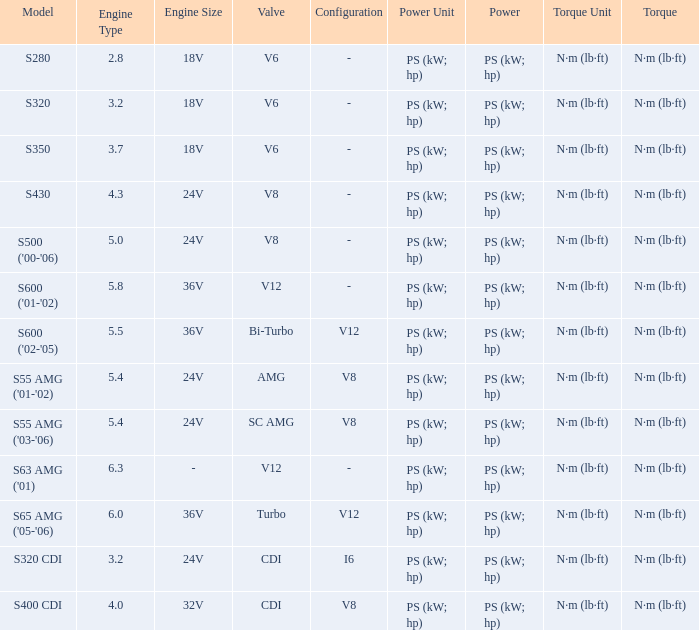Which Torque has a Model of s63 amg ('01)? N·m (lb·ft). 